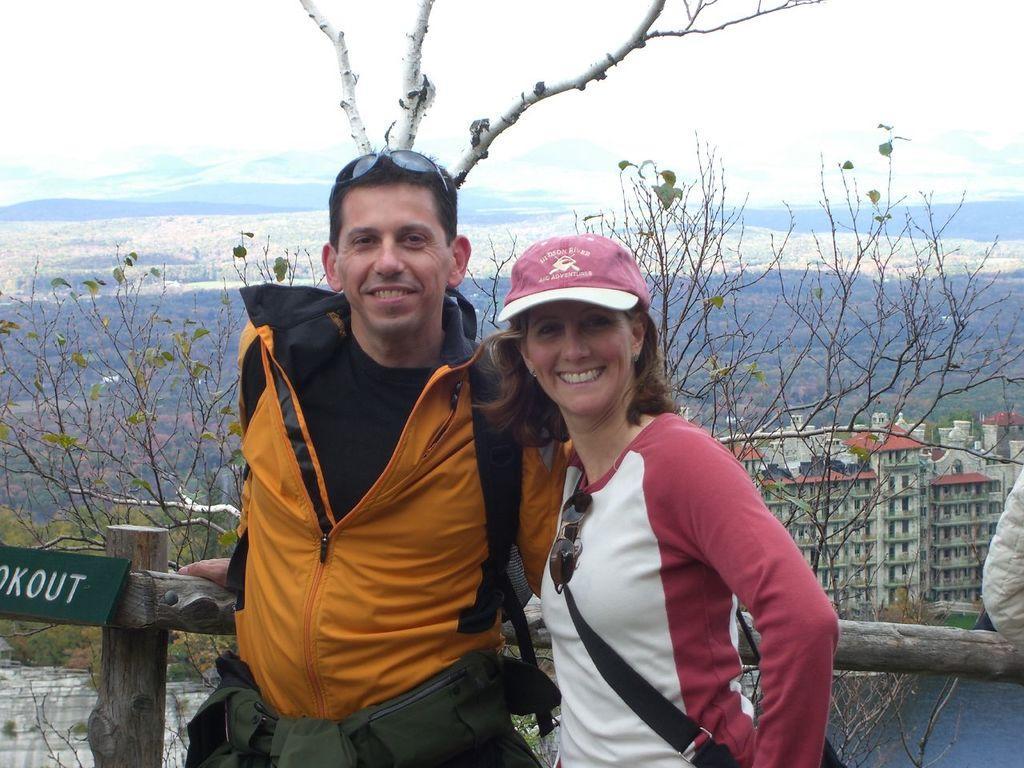Could you give a brief overview of what you see in this image? On the left side of the image there is a man with goggles on his head is standing. Beside him there is a lady with cap on her head is standing and she is smiling. Behind them there are wooden fencing poles and also there is a board with name on it. Behind them there is a tree. In the background there is a building, water and also there are hills. At the top of the image there is sky. 